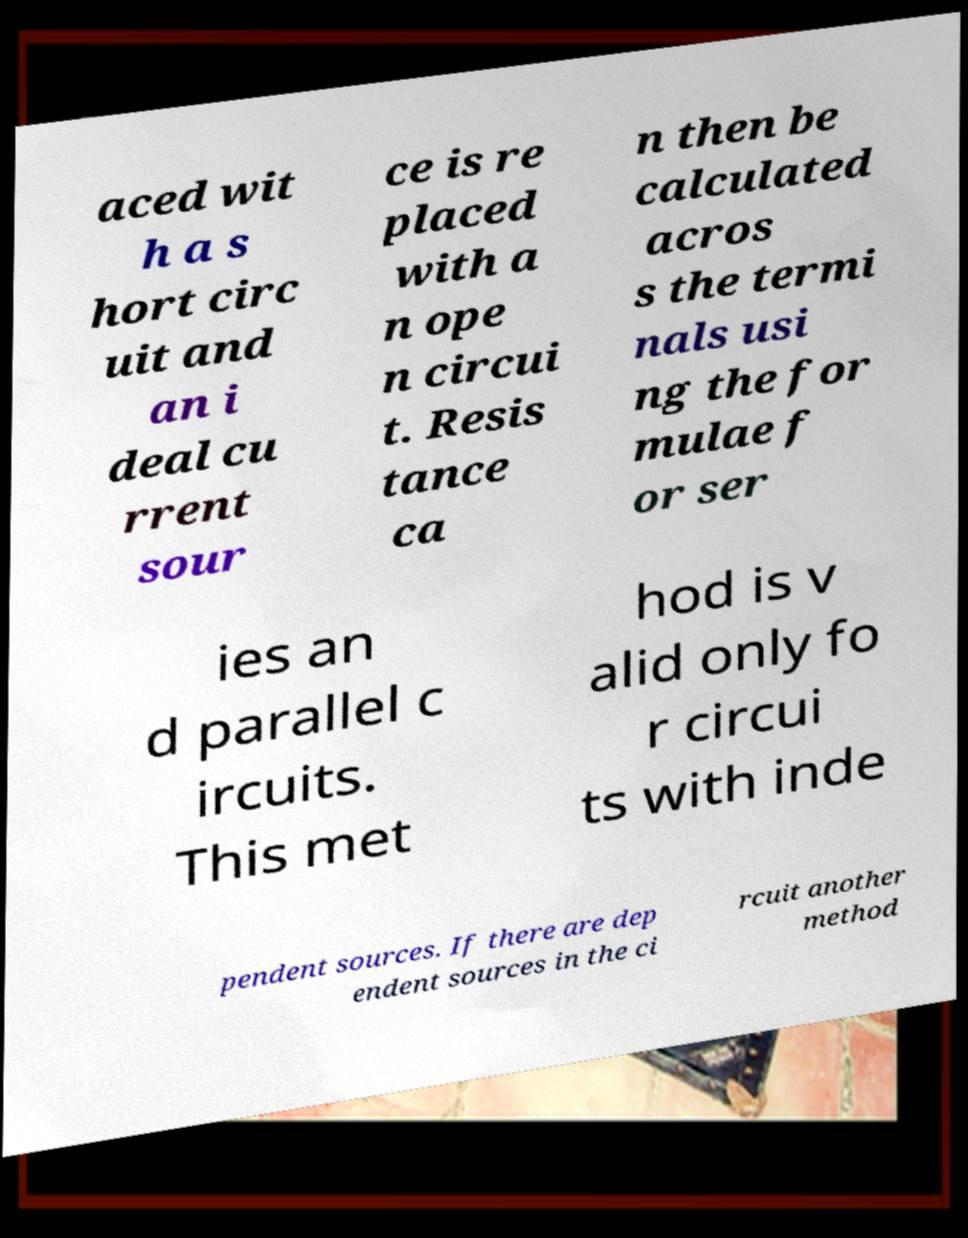Could you extract and type out the text from this image? aced wit h a s hort circ uit and an i deal cu rrent sour ce is re placed with a n ope n circui t. Resis tance ca n then be calculated acros s the termi nals usi ng the for mulae f or ser ies an d parallel c ircuits. This met hod is v alid only fo r circui ts with inde pendent sources. If there are dep endent sources in the ci rcuit another method 